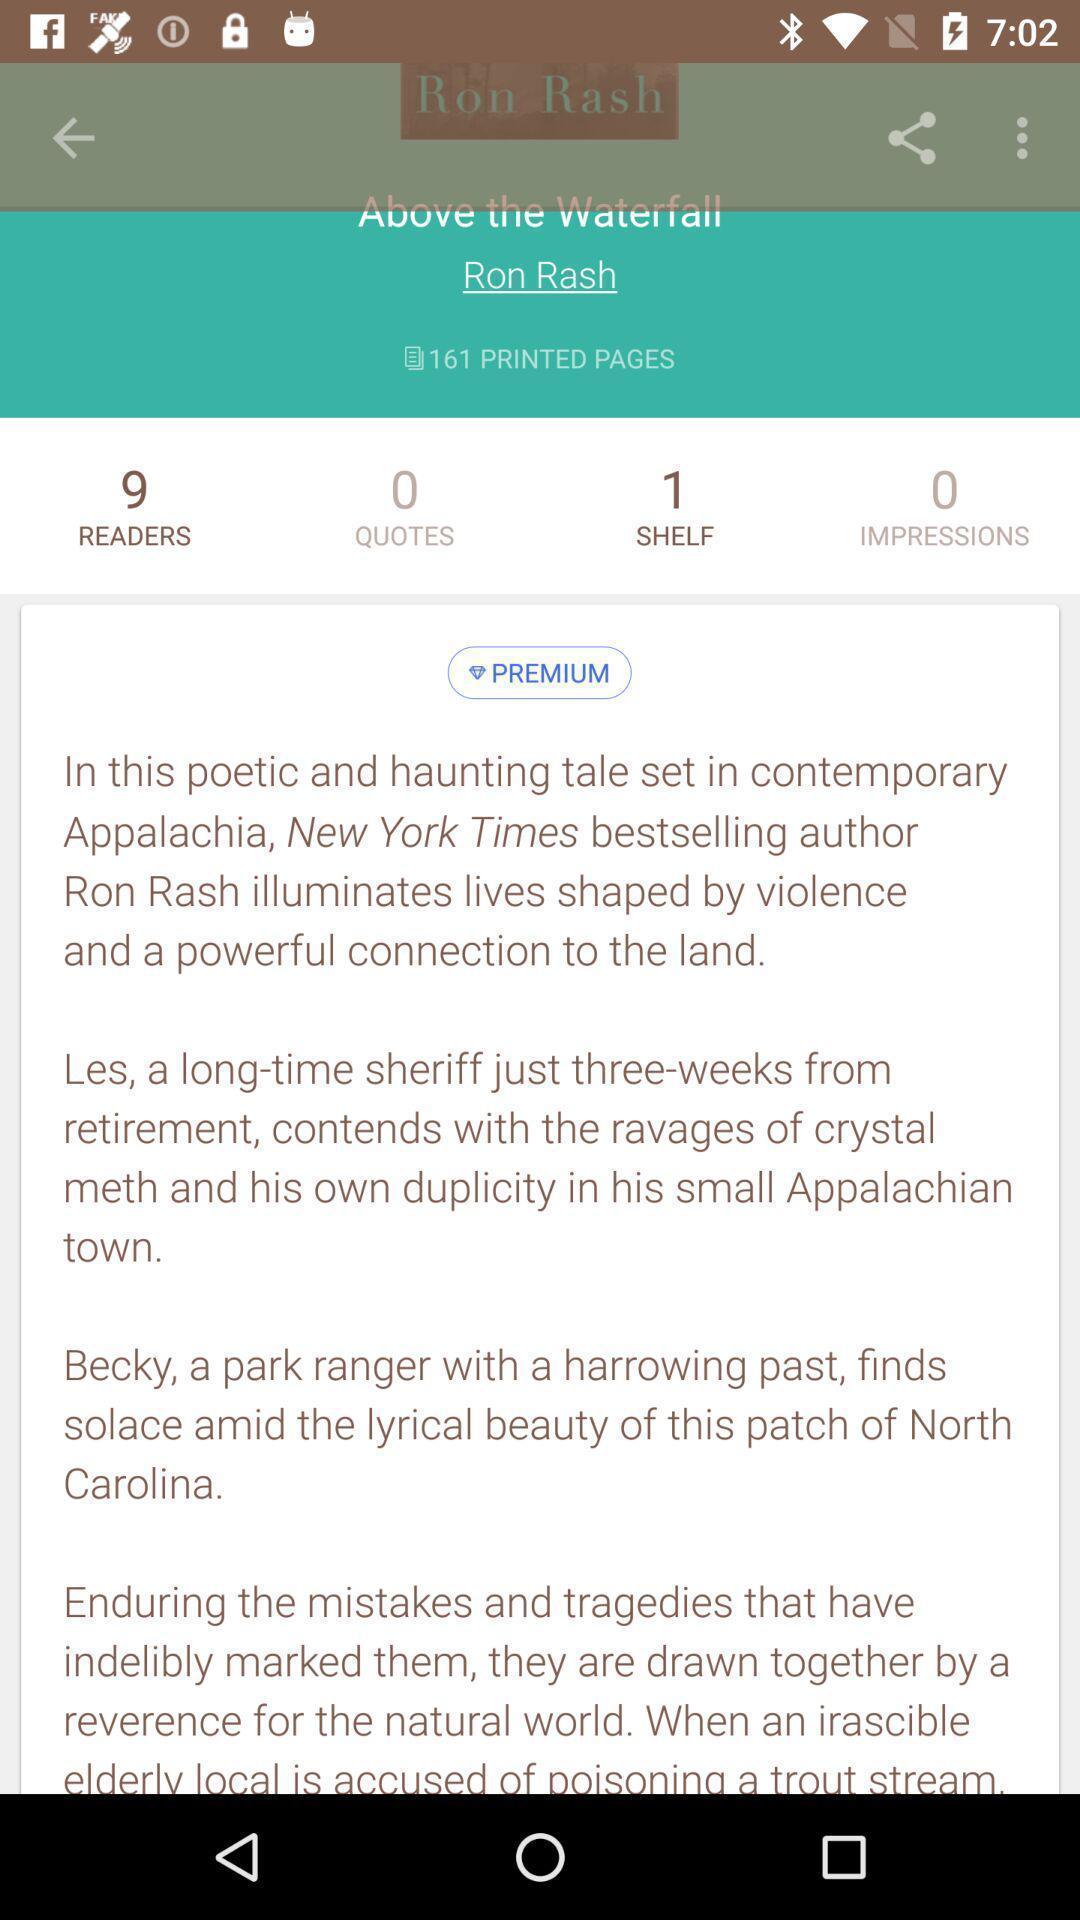What can you discern from this picture? Screen showing page of an reading application. 